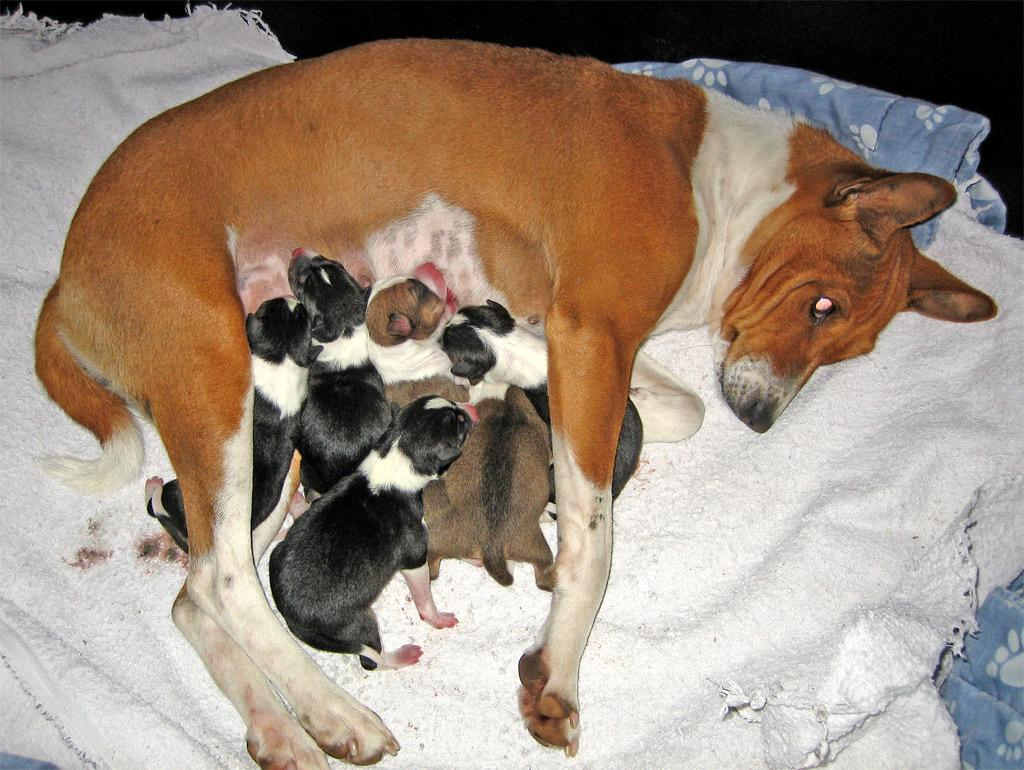What animal is present in the image? There is a dog in the image. Where is the dog located? The dog is laying on a white cloth. Are there any other animals on the white cloth? Yes, there are puppies on the white cloth. What is the home rate of the dog in the image? There is no information about the dog's home or any rates in the image. 